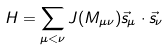<formula> <loc_0><loc_0><loc_500><loc_500>H = \sum _ { \mu < \nu } J ( M _ { \mu \nu } ) \vec { s } _ { \mu } \cdot \vec { s } _ { \nu }</formula> 